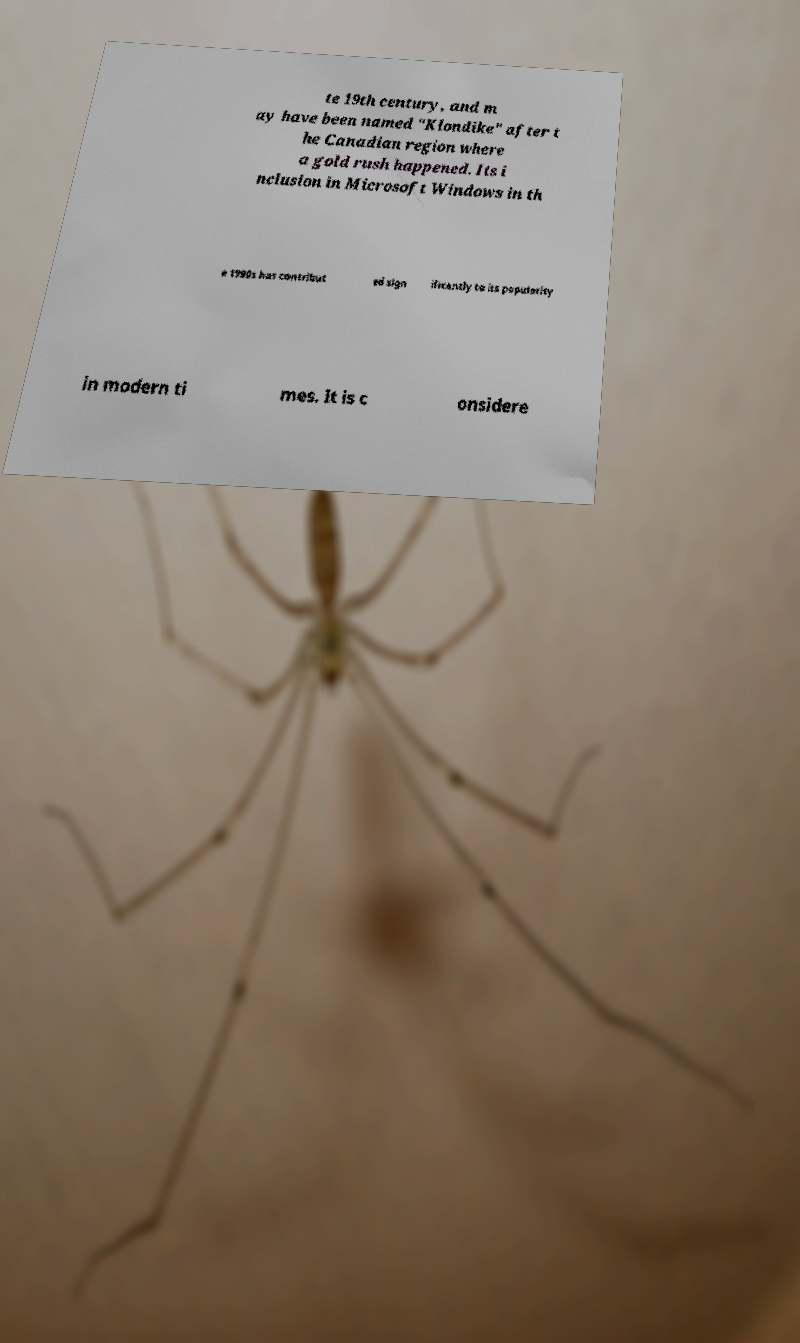I need the written content from this picture converted into text. Can you do that? te 19th century, and m ay have been named "Klondike" after t he Canadian region where a gold rush happened. Its i nclusion in Microsoft Windows in th e 1990s has contribut ed sign ificantly to its popularity in modern ti mes. It is c onsidere 